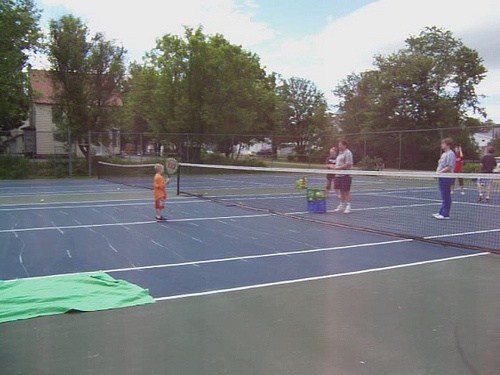Describe the objects in this image and their specific colors. I can see people in gray, brown, darkgray, and purple tones, people in gray, purple, and darkgray tones, people in gray and brown tones, people in gray and purple tones, and people in gray, brown, and maroon tones in this image. 